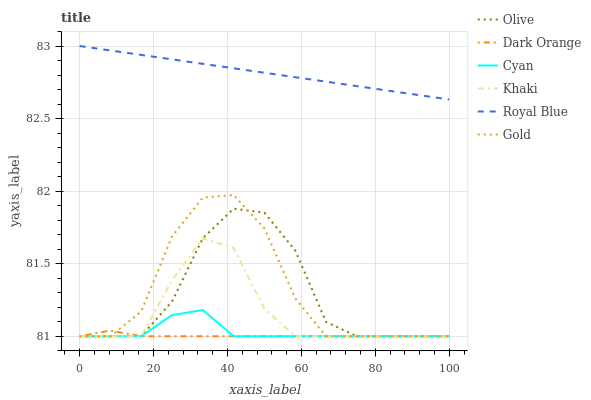Does Dark Orange have the minimum area under the curve?
Answer yes or no. Yes. Does Royal Blue have the maximum area under the curve?
Answer yes or no. Yes. Does Khaki have the minimum area under the curve?
Answer yes or no. No. Does Khaki have the maximum area under the curve?
Answer yes or no. No. Is Royal Blue the smoothest?
Answer yes or no. Yes. Is Gold the roughest?
Answer yes or no. Yes. Is Khaki the smoothest?
Answer yes or no. No. Is Khaki the roughest?
Answer yes or no. No. Does Dark Orange have the lowest value?
Answer yes or no. Yes. Does Royal Blue have the lowest value?
Answer yes or no. No. Does Royal Blue have the highest value?
Answer yes or no. Yes. Does Khaki have the highest value?
Answer yes or no. No. Is Dark Orange less than Royal Blue?
Answer yes or no. Yes. Is Royal Blue greater than Olive?
Answer yes or no. Yes. Does Cyan intersect Gold?
Answer yes or no. Yes. Is Cyan less than Gold?
Answer yes or no. No. Is Cyan greater than Gold?
Answer yes or no. No. Does Dark Orange intersect Royal Blue?
Answer yes or no. No. 